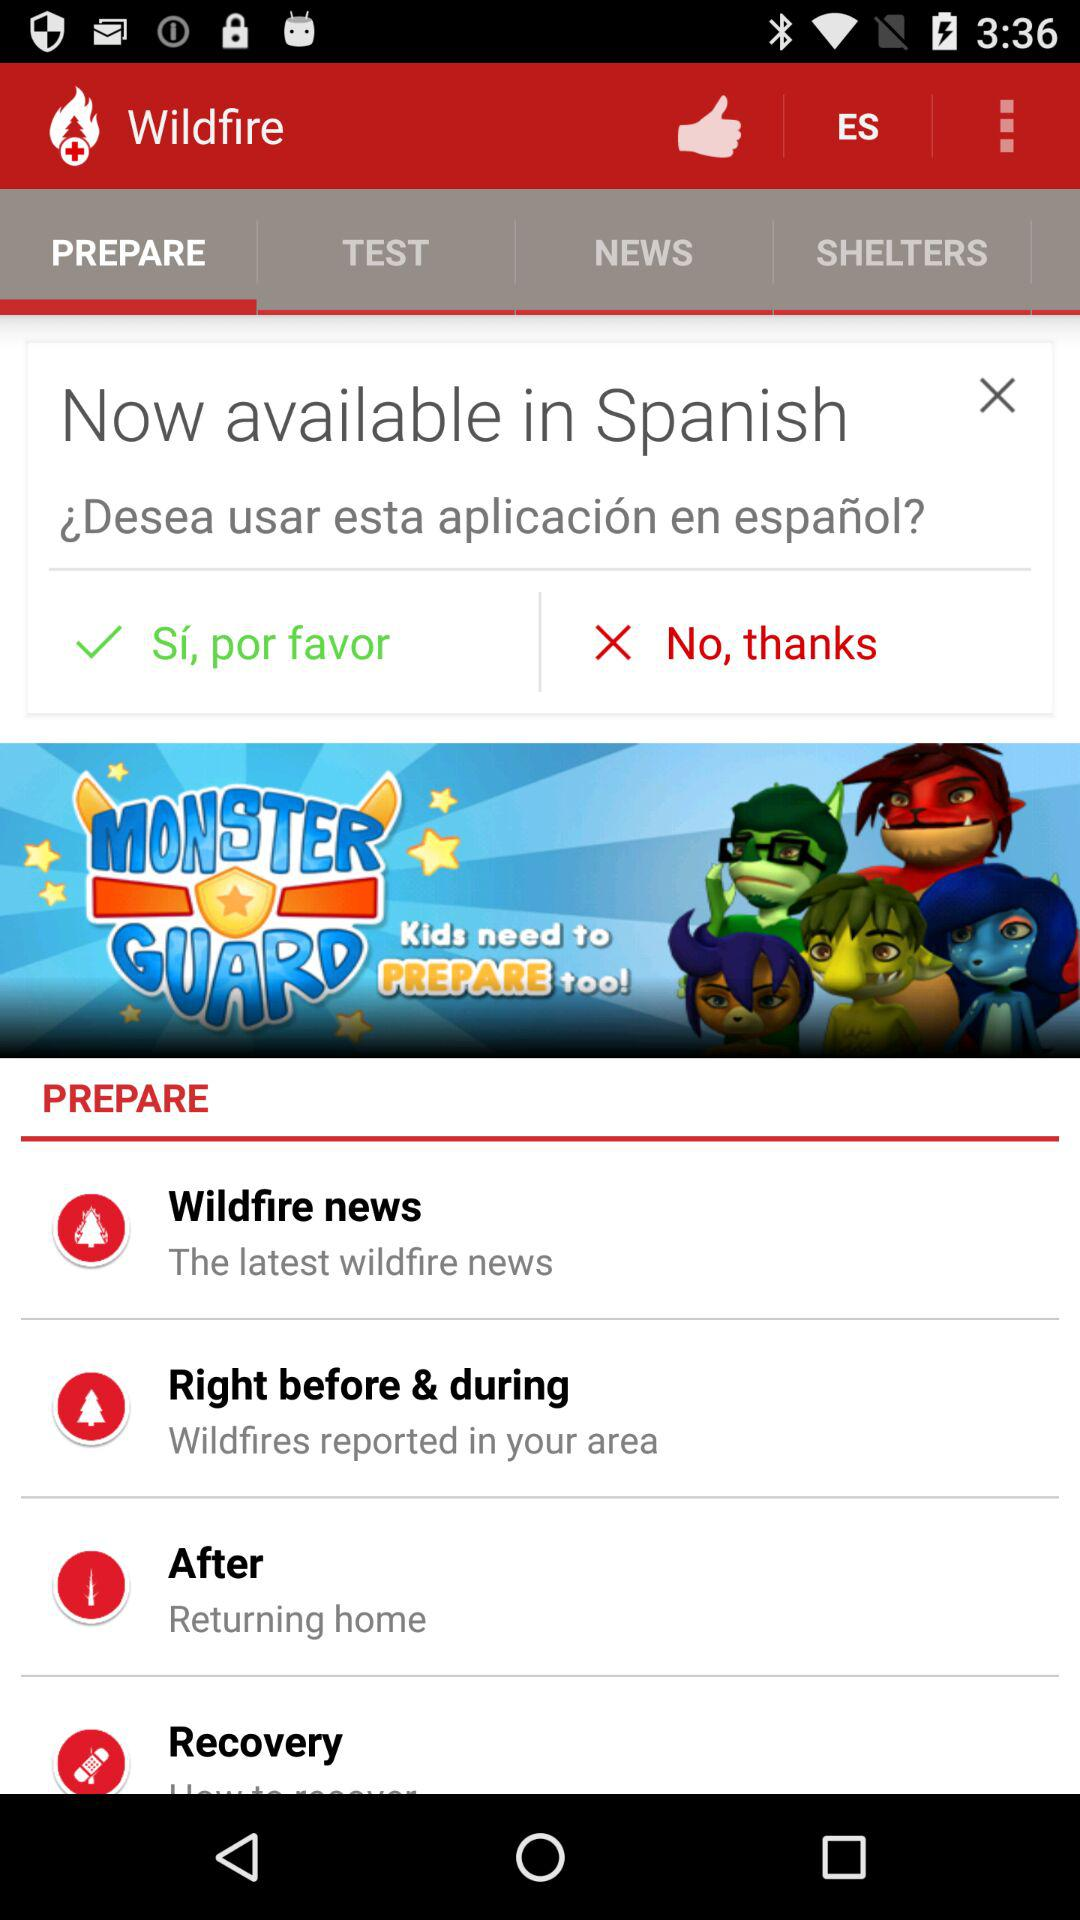Which tab is selected? The selected tab is "PREPARE". 